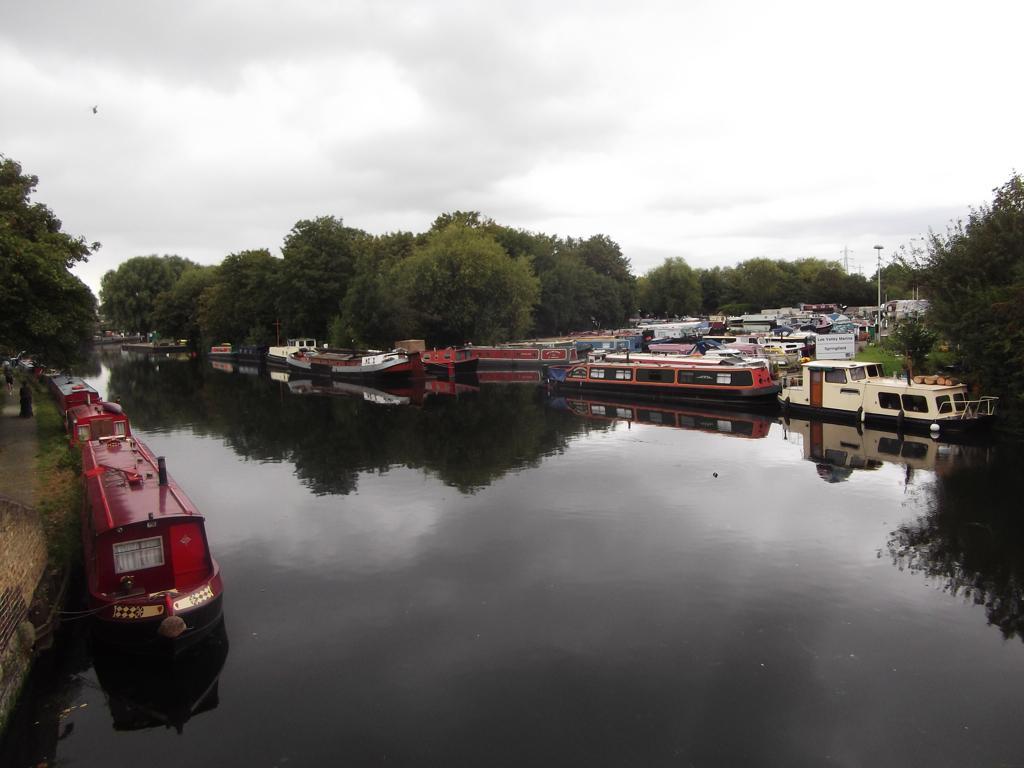Describe this image in one or two sentences. In the image in the center, we can see a few boats on the water. In the background, we can see the sky, clouds, trees, boats etc. 